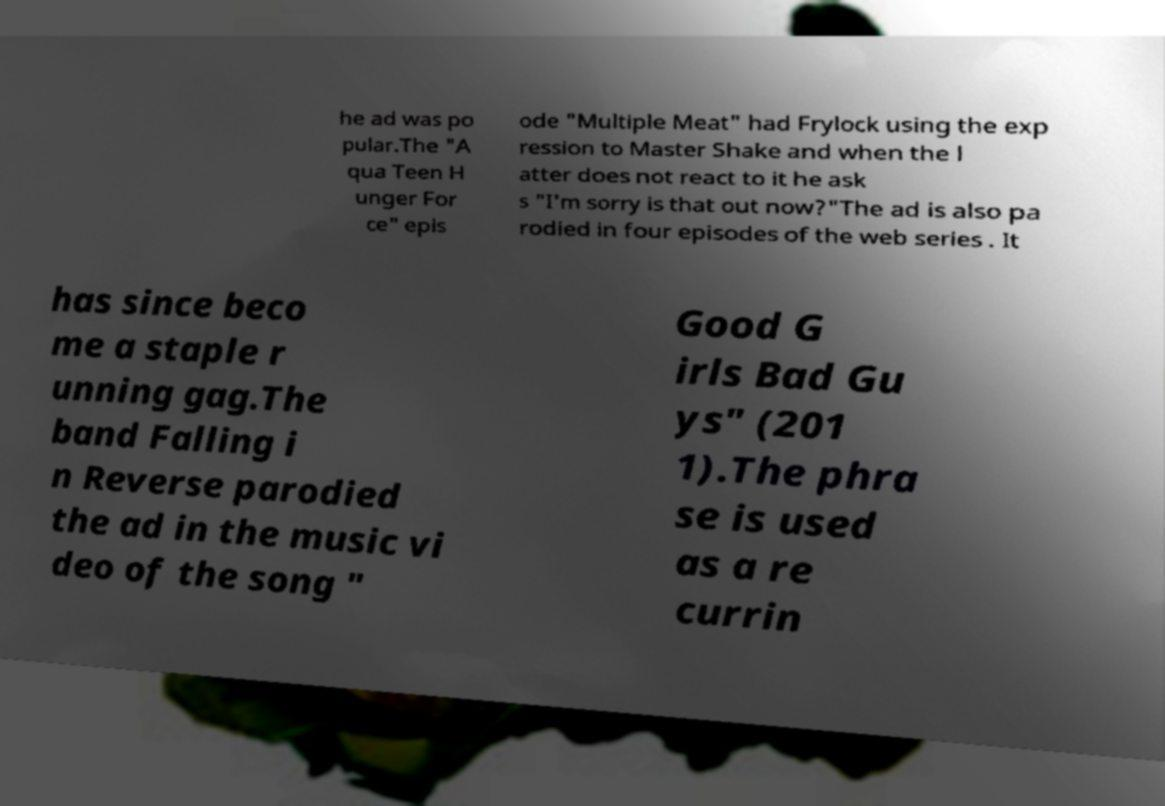Can you accurately transcribe the text from the provided image for me? he ad was po pular.The "A qua Teen H unger For ce" epis ode "Multiple Meat" had Frylock using the exp ression to Master Shake and when the l atter does not react to it he ask s "I'm sorry is that out now?"The ad is also pa rodied in four episodes of the web series . It has since beco me a staple r unning gag.The band Falling i n Reverse parodied the ad in the music vi deo of the song " Good G irls Bad Gu ys" (201 1).The phra se is used as a re currin 